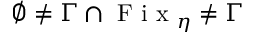<formula> <loc_0><loc_0><loc_500><loc_500>\emptyset \neq \Gamma \cap F i x _ { \eta } \neq \Gamma</formula> 